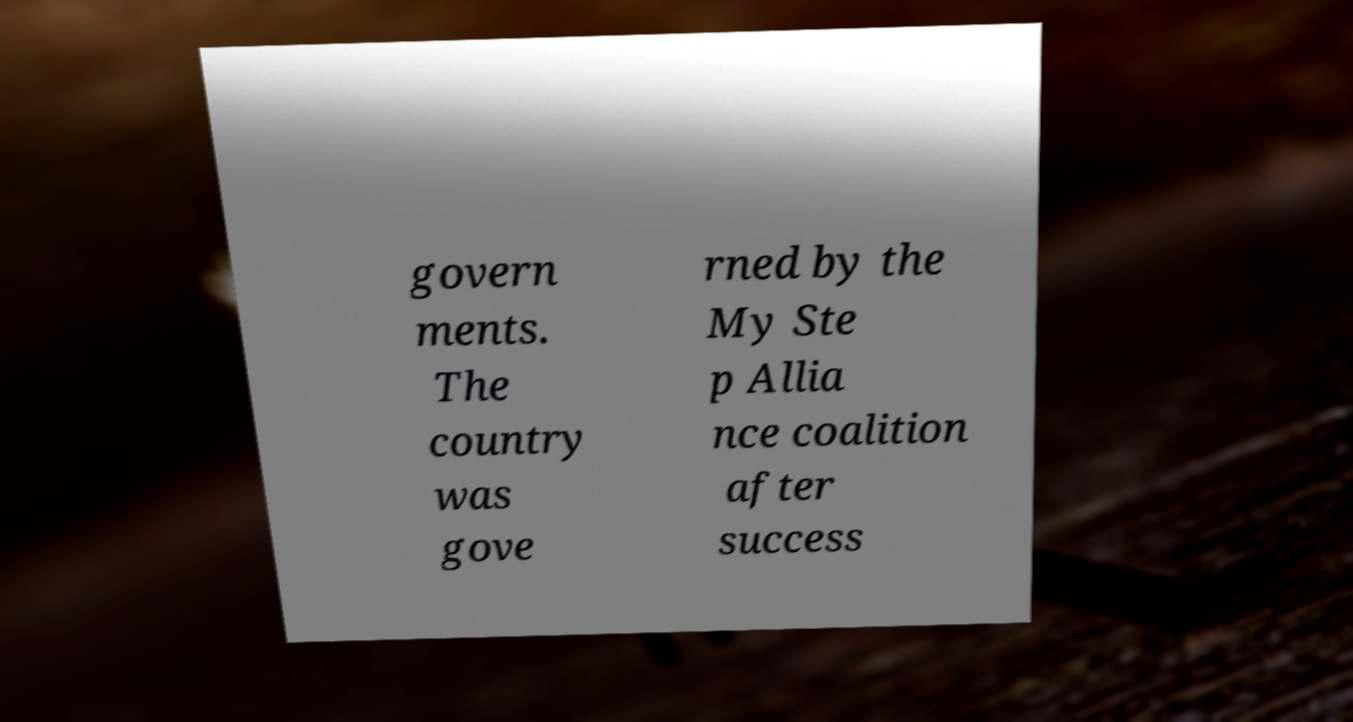Please identify and transcribe the text found in this image. govern ments. The country was gove rned by the My Ste p Allia nce coalition after success 